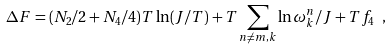Convert formula to latex. <formula><loc_0><loc_0><loc_500><loc_500>\Delta F = ( N _ { 2 } / 2 + N _ { 4 } / 4 ) T \ln ( J / T ) + T \sum _ { n \neq m , k } \ln \omega _ { k } ^ { n } / J + T f _ { 4 } \ ,</formula> 